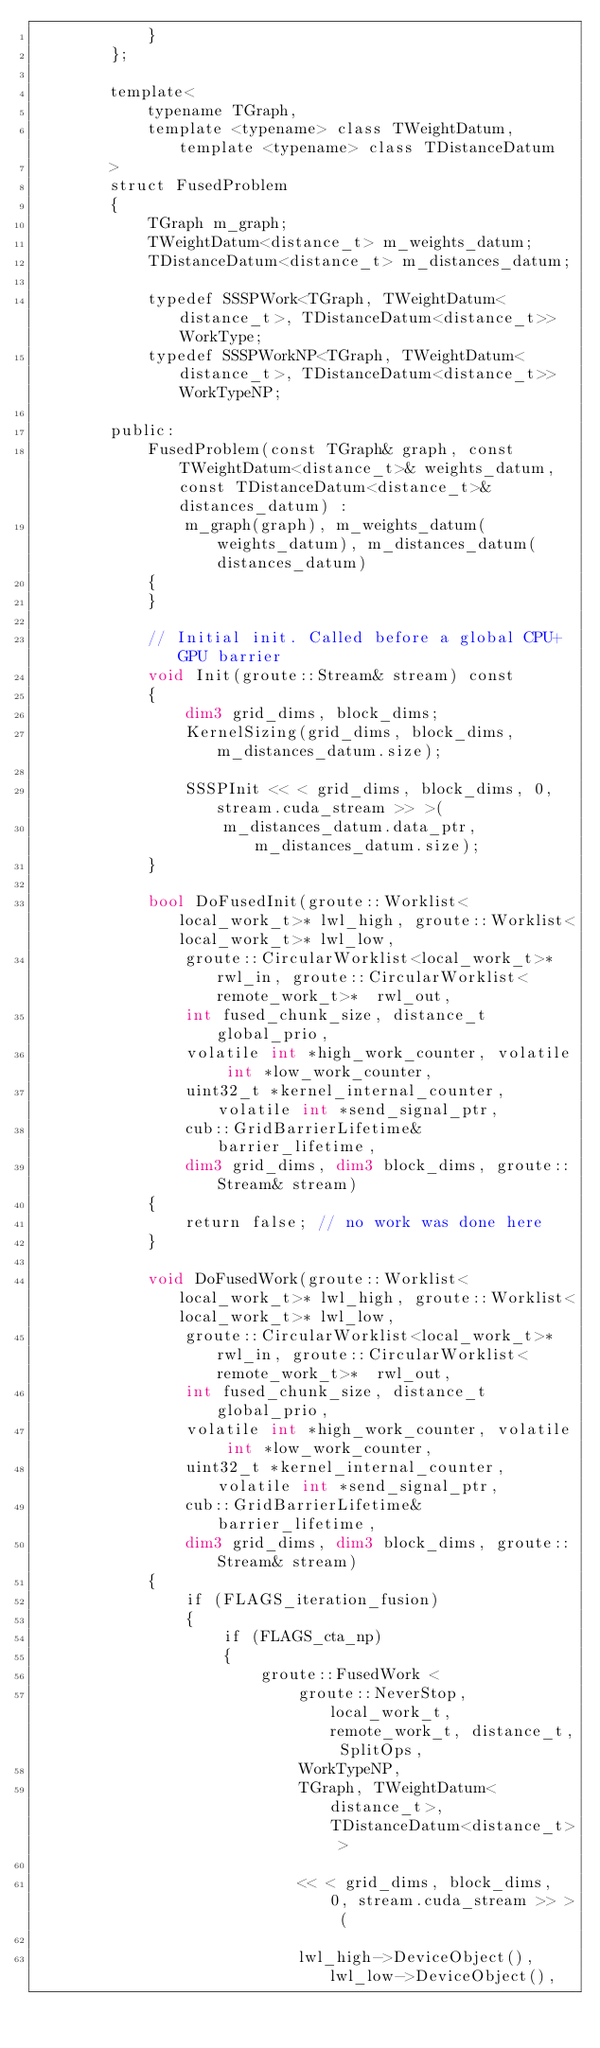<code> <loc_0><loc_0><loc_500><loc_500><_Cuda_>            }
        };

        template<
            typename TGraph,
            template <typename> class TWeightDatum, template <typename> class TDistanceDatum
        >
        struct FusedProblem
        {
            TGraph m_graph;
            TWeightDatum<distance_t> m_weights_datum;
            TDistanceDatum<distance_t> m_distances_datum;

            typedef SSSPWork<TGraph, TWeightDatum<distance_t>, TDistanceDatum<distance_t>> WorkType;
            typedef SSSPWorkNP<TGraph, TWeightDatum<distance_t>, TDistanceDatum<distance_t>> WorkTypeNP;

        public:
            FusedProblem(const TGraph& graph, const TWeightDatum<distance_t>& weights_datum, const TDistanceDatum<distance_t>& distances_datum) :
                m_graph(graph), m_weights_datum(weights_datum), m_distances_datum(distances_datum)
            {
            }

            // Initial init. Called before a global CPU+GPU barrier
            void Init(groute::Stream& stream) const
            {
                dim3 grid_dims, block_dims;
                KernelSizing(grid_dims, block_dims, m_distances_datum.size);

                SSSPInit << < grid_dims, block_dims, 0, stream.cuda_stream >> >(
                    m_distances_datum.data_ptr, m_distances_datum.size);
            }

            bool DoFusedInit(groute::Worklist<local_work_t>* lwl_high, groute::Worklist<local_work_t>* lwl_low,
                groute::CircularWorklist<local_work_t>*  rwl_in, groute::CircularWorklist<remote_work_t>*  rwl_out,
                int fused_chunk_size, distance_t global_prio,
                volatile int *high_work_counter, volatile int *low_work_counter,
                uint32_t *kernel_internal_counter, volatile int *send_signal_ptr,
                cub::GridBarrierLifetime& barrier_lifetime,
                dim3 grid_dims, dim3 block_dims, groute::Stream& stream)
            {
                return false; // no work was done here
            }

            void DoFusedWork(groute::Worklist<local_work_t>* lwl_high, groute::Worklist<local_work_t>* lwl_low,
                groute::CircularWorklist<local_work_t>*  rwl_in, groute::CircularWorklist<remote_work_t>*  rwl_out,
                int fused_chunk_size, distance_t global_prio,
                volatile int *high_work_counter, volatile int *low_work_counter,
                uint32_t *kernel_internal_counter, volatile int *send_signal_ptr,
                cub::GridBarrierLifetime& barrier_lifetime,
                dim3 grid_dims, dim3 block_dims, groute::Stream& stream)
            {
                if (FLAGS_iteration_fusion)
                {
                    if (FLAGS_cta_np)
                    {
                        groute::FusedWork <
                            groute::NeverStop, local_work_t, remote_work_t, distance_t, SplitOps,
                            WorkTypeNP,
                            TGraph, TWeightDatum<distance_t>, TDistanceDatum<distance_t> >

                            << < grid_dims, block_dims, 0, stream.cuda_stream >> > (

                            lwl_high->DeviceObject(), lwl_low->DeviceObject(),</code> 